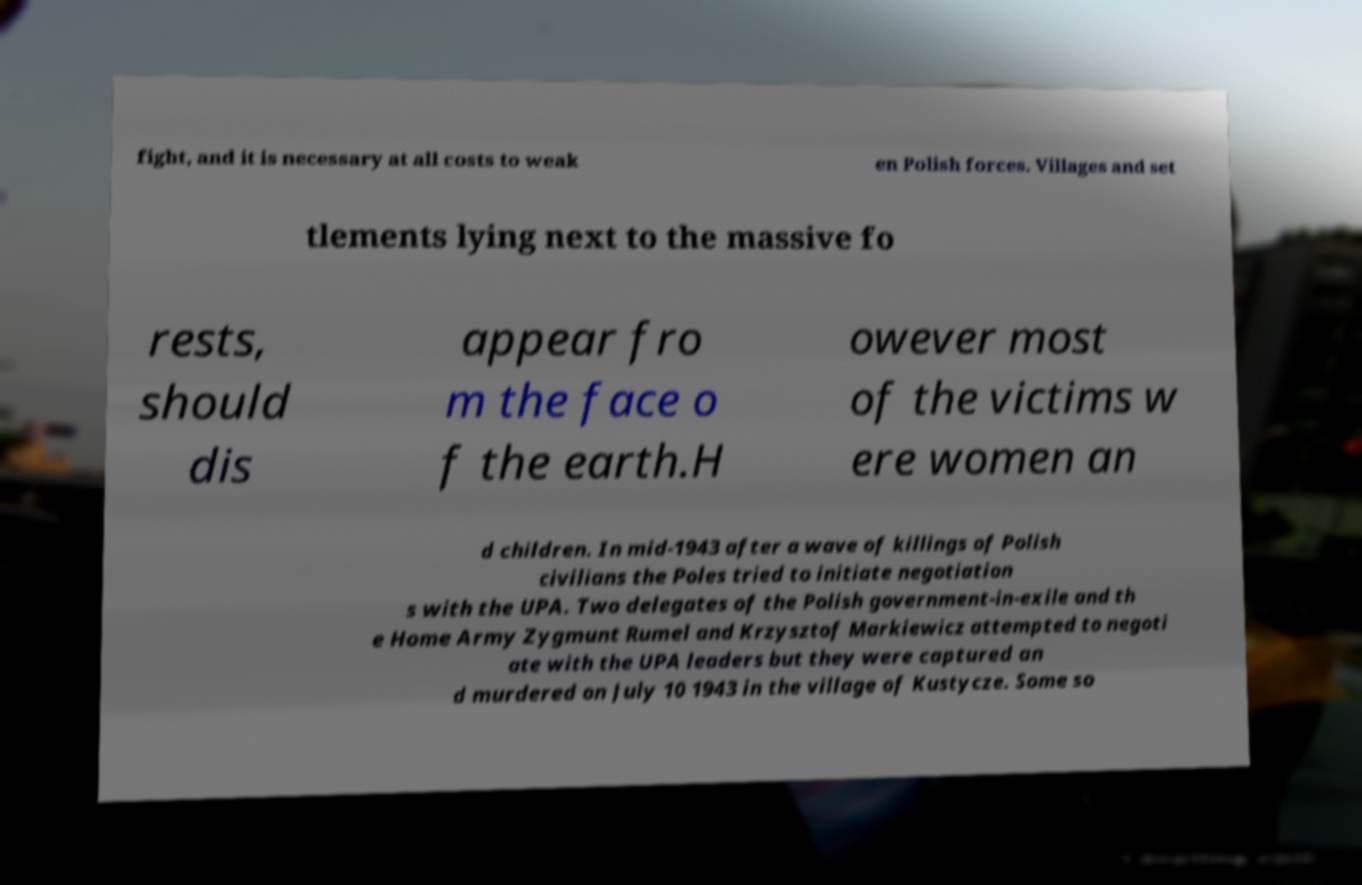For documentation purposes, I need the text within this image transcribed. Could you provide that? fight, and it is necessary at all costs to weak en Polish forces. Villages and set tlements lying next to the massive fo rests, should dis appear fro m the face o f the earth.H owever most of the victims w ere women an d children. In mid-1943 after a wave of killings of Polish civilians the Poles tried to initiate negotiation s with the UPA. Two delegates of the Polish government-in-exile and th e Home Army Zygmunt Rumel and Krzysztof Markiewicz attempted to negoti ate with the UPA leaders but they were captured an d murdered on July 10 1943 in the village of Kustycze. Some so 